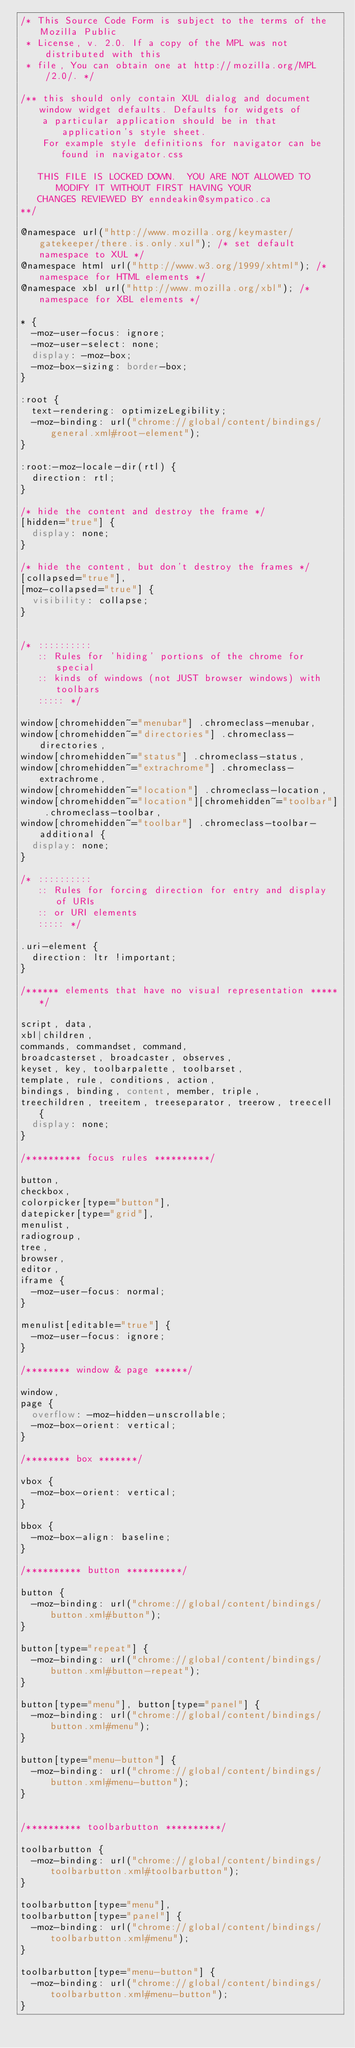<code> <loc_0><loc_0><loc_500><loc_500><_CSS_>/* This Source Code Form is subject to the terms of the Mozilla Public
 * License, v. 2.0. If a copy of the MPL was not distributed with this
 * file, You can obtain one at http://mozilla.org/MPL/2.0/. */

/** this should only contain XUL dialog and document window widget defaults. Defaults for widgets of
    a particular application should be in that application's style sheet.
	For example style definitions for navigator can be found in navigator.css

   THIS FILE IS LOCKED DOWN.  YOU ARE NOT ALLOWED TO MODIFY IT WITHOUT FIRST HAVING YOUR
   CHANGES REVIEWED BY enndeakin@sympatico.ca
**/

@namespace url("http://www.mozilla.org/keymaster/gatekeeper/there.is.only.xul"); /* set default namespace to XUL */
@namespace html url("http://www.w3.org/1999/xhtml"); /* namespace for HTML elements */
@namespace xbl url("http://www.mozilla.org/xbl"); /* namespace for XBL elements */

* {
  -moz-user-focus: ignore;
  -moz-user-select: none;
  display: -moz-box;
  -moz-box-sizing: border-box;
}

:root {
  text-rendering: optimizeLegibility;
  -moz-binding: url("chrome://global/content/bindings/general.xml#root-element");
}

:root:-moz-locale-dir(rtl) {
  direction: rtl;
}

/* hide the content and destroy the frame */
[hidden="true"] {
  display: none;
}

/* hide the content, but don't destroy the frames */
[collapsed="true"],
[moz-collapsed="true"] {
  visibility: collapse;
}


/* ::::::::::
   :: Rules for 'hiding' portions of the chrome for special
   :: kinds of windows (not JUST browser windows) with toolbars
   ::::: */

window[chromehidden~="menubar"] .chromeclass-menubar,
window[chromehidden~="directories"] .chromeclass-directories,
window[chromehidden~="status"] .chromeclass-status,
window[chromehidden~="extrachrome"] .chromeclass-extrachrome,
window[chromehidden~="location"] .chromeclass-location,
window[chromehidden~="location"][chromehidden~="toolbar"] .chromeclass-toolbar,
window[chromehidden~="toolbar"] .chromeclass-toolbar-additional {
  display: none;
}

/* ::::::::::
   :: Rules for forcing direction for entry and display of URIs
   :: or URI elements
   ::::: */

.uri-element {
  direction: ltr !important;
}

/****** elements that have no visual representation ******/

script, data,
xbl|children,
commands, commandset, command,
broadcasterset, broadcaster, observes,
keyset, key, toolbarpalette, toolbarset,
template, rule, conditions, action,
bindings, binding, content, member, triple,
treechildren, treeitem, treeseparator, treerow, treecell {
  display: none;
}

/********** focus rules **********/

button,
checkbox,
colorpicker[type="button"],
datepicker[type="grid"],
menulist,
radiogroup,
tree,
browser,
editor,
iframe {
  -moz-user-focus: normal;
}

menulist[editable="true"] {
  -moz-user-focus: ignore;
}

/******** window & page ******/

window,
page {
  overflow: -moz-hidden-unscrollable;
  -moz-box-orient: vertical;
}

/******** box *******/

vbox {
  -moz-box-orient: vertical;
}

bbox {
  -moz-box-align: baseline;
}

/********** button **********/

button {
  -moz-binding: url("chrome://global/content/bindings/button.xml#button");
}

button[type="repeat"] {
  -moz-binding: url("chrome://global/content/bindings/button.xml#button-repeat");
}

button[type="menu"], button[type="panel"] {
  -moz-binding: url("chrome://global/content/bindings/button.xml#menu");
}

button[type="menu-button"] {
  -moz-binding: url("chrome://global/content/bindings/button.xml#menu-button");
}


/********** toolbarbutton **********/

toolbarbutton {
  -moz-binding: url("chrome://global/content/bindings/toolbarbutton.xml#toolbarbutton");
}

toolbarbutton[type="menu"],
toolbarbutton[type="panel"] {
  -moz-binding: url("chrome://global/content/bindings/toolbarbutton.xml#menu");
}

toolbarbutton[type="menu-button"] {
  -moz-binding: url("chrome://global/content/bindings/toolbarbutton.xml#menu-button");
}
</code> 